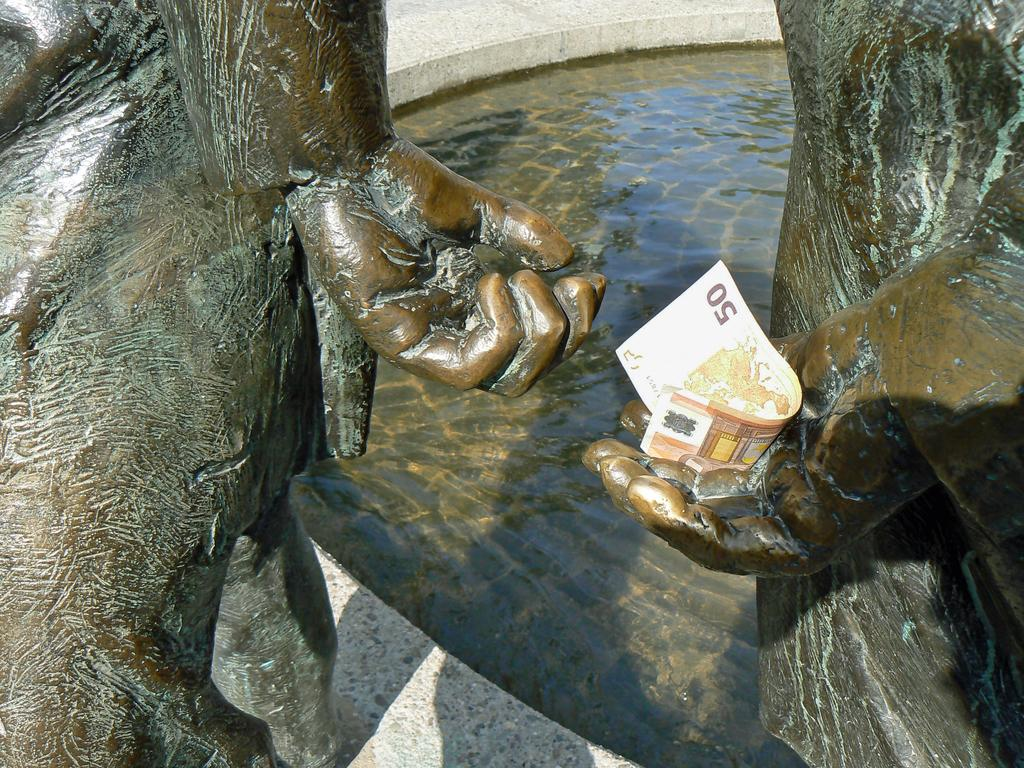What type of container is visible in the image? There is a concrete water tub in the image. What other objects can be seen in the image? There are sculptures in the image. Can you describe the interaction between the sculptures and the currency note? A currency note is held by one of the sculptures. How many frogs are sitting on the lace in the image? There are no frogs or lace present in the image. What type of twist can be seen in the sculptures' poses? There is no mention of any twists in the sculptures' poses in the provided facts. 